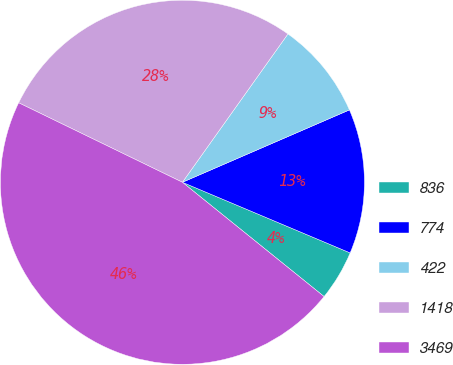Convert chart to OTSL. <chart><loc_0><loc_0><loc_500><loc_500><pie_chart><fcel>836<fcel>774<fcel>422<fcel>1418<fcel>3469<nl><fcel>4.46%<fcel>12.85%<fcel>8.65%<fcel>27.65%<fcel>46.39%<nl></chart> 